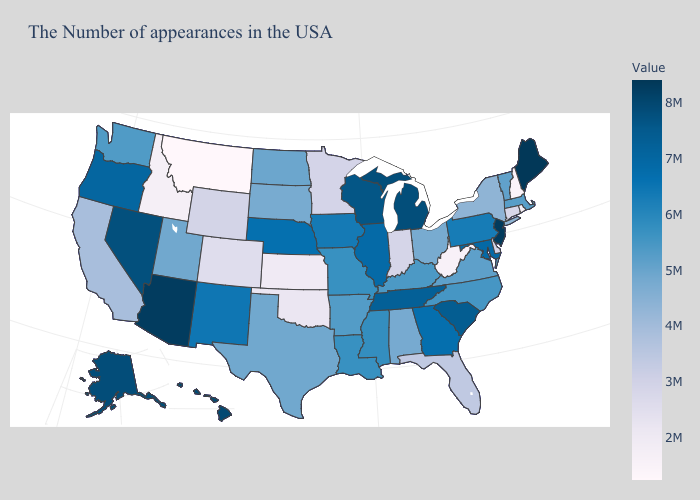Does West Virginia have the lowest value in the South?
Quick response, please. Yes. Does Arkansas have a lower value than Oklahoma?
Keep it brief. No. Among the states that border New Hampshire , does Vermont have the lowest value?
Be succinct. Yes. Which states have the highest value in the USA?
Keep it brief. Maine. 